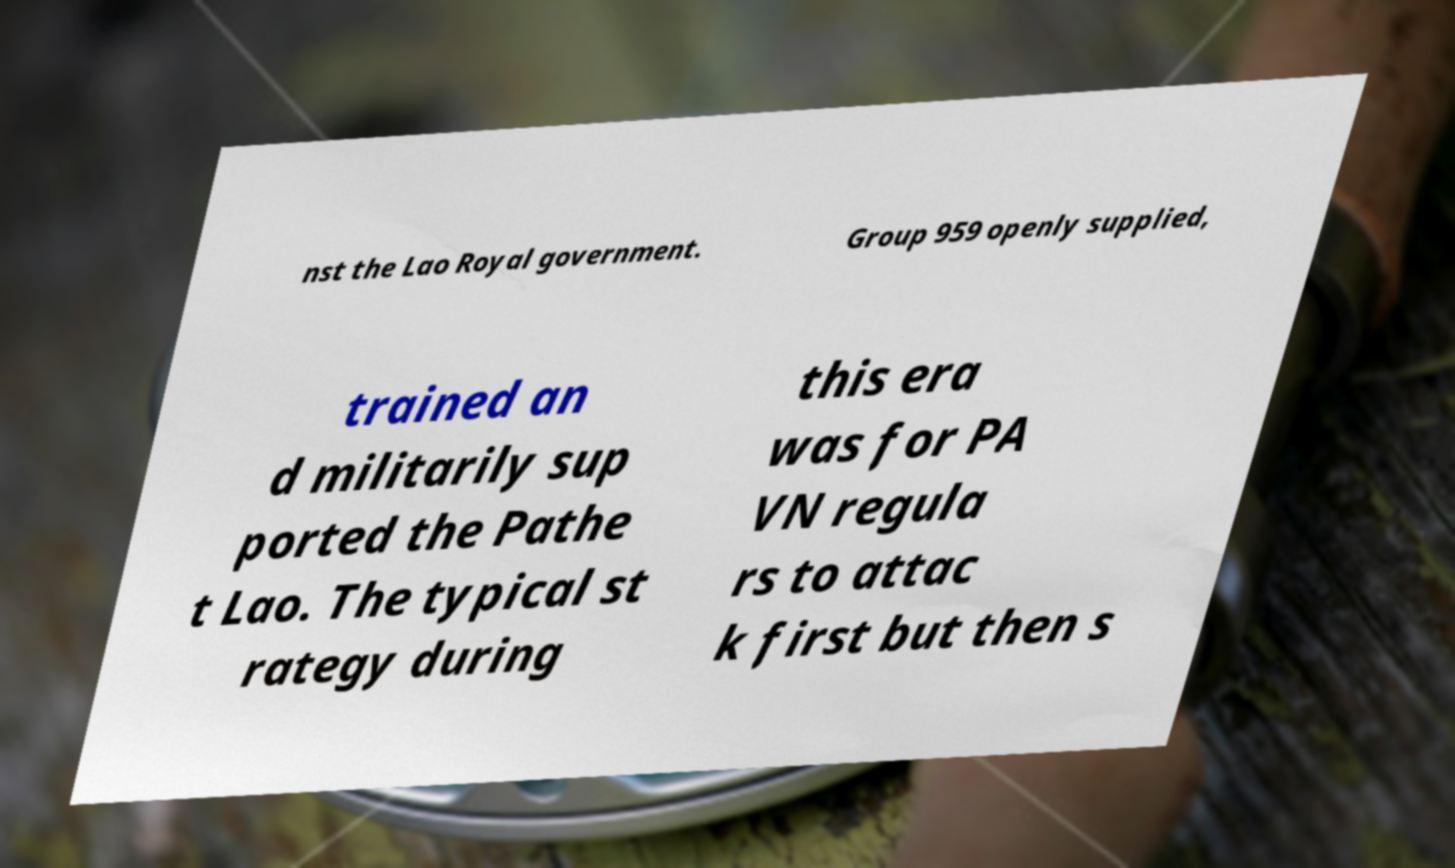Can you read and provide the text displayed in the image?This photo seems to have some interesting text. Can you extract and type it out for me? nst the Lao Royal government. Group 959 openly supplied, trained an d militarily sup ported the Pathe t Lao. The typical st rategy during this era was for PA VN regula rs to attac k first but then s 